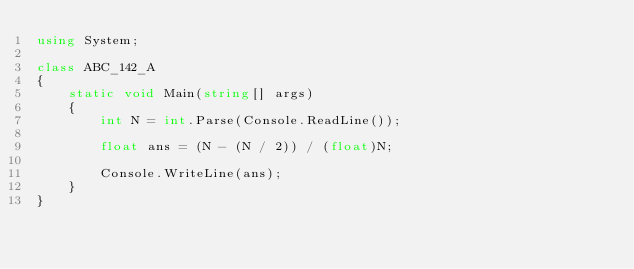<code> <loc_0><loc_0><loc_500><loc_500><_C#_>using System;

class ABC_142_A
{
    static void Main(string[] args)
    {
        int N = int.Parse(Console.ReadLine());

        float ans = (N - (N / 2)) / (float)N;

        Console.WriteLine(ans);
    }
}
</code> 